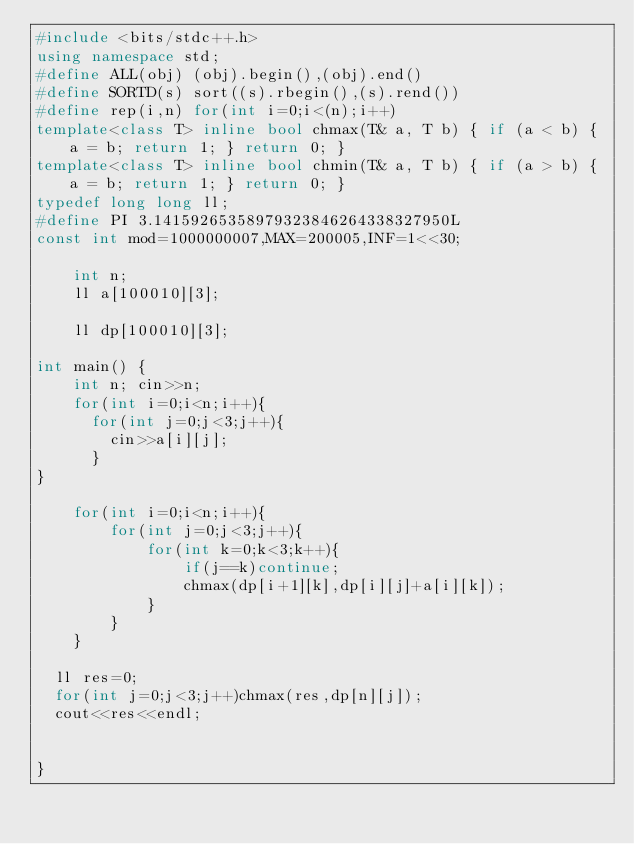Convert code to text. <code><loc_0><loc_0><loc_500><loc_500><_C++_>#include <bits/stdc++.h>
using namespace std;
#define ALL(obj) (obj).begin(),(obj).end()
#define SORTD(s) sort((s).rbegin(),(s).rend())
#define rep(i,n) for(int i=0;i<(n);i++)
template<class T> inline bool chmax(T& a, T b) { if (a < b) { a = b; return 1; } return 0; }
template<class T> inline bool chmin(T& a, T b) { if (a > b) { a = b; return 1; } return 0; }
typedef long long ll;
#define PI 3.14159265358979323846264338327950L
const int mod=1000000007,MAX=200005,INF=1<<30;

	int n;
  	ll a[100010][3];
  
  	ll dp[100010][3];

int main() {
	int n; cin>>n;
  	for(int i=0;i<n;i++){
      for(int j=0;j<3;j++){
      	cin>>a[i][j];
      }
}

	for(int i=0;i<n;i++){
    	for(int j=0;j<3;j++){
        	for(int k=0;k<3;k++){
            	if(j==k)continue;
              	chmax(dp[i+1][k],dp[i][j]+a[i][k]);
            }
        }
    }
  
  ll res=0;
  for(int j=0;j<3;j++)chmax(res,dp[n][j]);
  cout<<res<<endl;


}</code> 